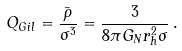Convert formula to latex. <formula><loc_0><loc_0><loc_500><loc_500>Q _ { G i l } = \frac { \bar { \rho } } { \sigma ^ { 3 } } = \frac { 3 } { 8 \pi G _ { N } r _ { h } ^ { 2 } \sigma } \, .</formula> 